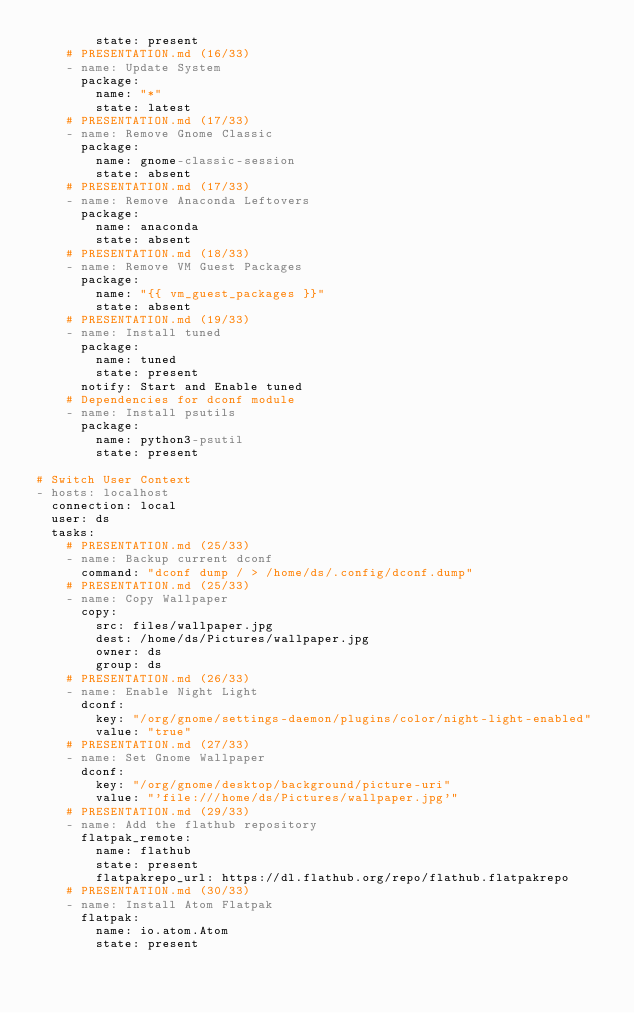<code> <loc_0><loc_0><loc_500><loc_500><_YAML_>        state: present
    # PRESENTATION.md (16/33)
    - name: Update System
      package:
        name: "*"
        state: latest
    # PRESENTATION.md (17/33)
    - name: Remove Gnome Classic
      package:
        name: gnome-classic-session
        state: absent
    # PRESENTATION.md (17/33)
    - name: Remove Anaconda Leftovers
      package:
        name: anaconda
        state: absent
    # PRESENTATION.md (18/33)
    - name: Remove VM Guest Packages
      package:
        name: "{{ vm_guest_packages }}"
        state: absent
    # PRESENTATION.md (19/33)
    - name: Install tuned
      package:
        name: tuned
        state: present
      notify: Start and Enable tuned
    # Dependencies for dconf module
    - name: Install psutils
      package:
        name: python3-psutil
        state: present

# Switch User Context
- hosts: localhost
  connection: local
  user: ds
  tasks:
    # PRESENTATION.md (25/33)
    - name: Backup current dconf
      command: "dconf dump / > /home/ds/.config/dconf.dump"
    # PRESENTATION.md (25/33)
    - name: Copy Wallpaper
      copy:
        src: files/wallpaper.jpg
        dest: /home/ds/Pictures/wallpaper.jpg
        owner: ds
        group: ds
    # PRESENTATION.md (26/33)
    - name: Enable Night Light
      dconf:
        key: "/org/gnome/settings-daemon/plugins/color/night-light-enabled"
        value: "true"
    # PRESENTATION.md (27/33)
    - name: Set Gnome Wallpaper
      dconf:
        key: "/org/gnome/desktop/background/picture-uri"
        value: "'file:///home/ds/Pictures/wallpaper.jpg'"
    # PRESENTATION.md (29/33)
    - name: Add the flathub repository
      flatpak_remote:
        name: flathub
        state: present
        flatpakrepo_url: https://dl.flathub.org/repo/flathub.flatpakrepo
    # PRESENTATION.md (30/33)
    - name: Install Atom Flatpak
      flatpak:
        name: io.atom.Atom
        state: present
</code> 